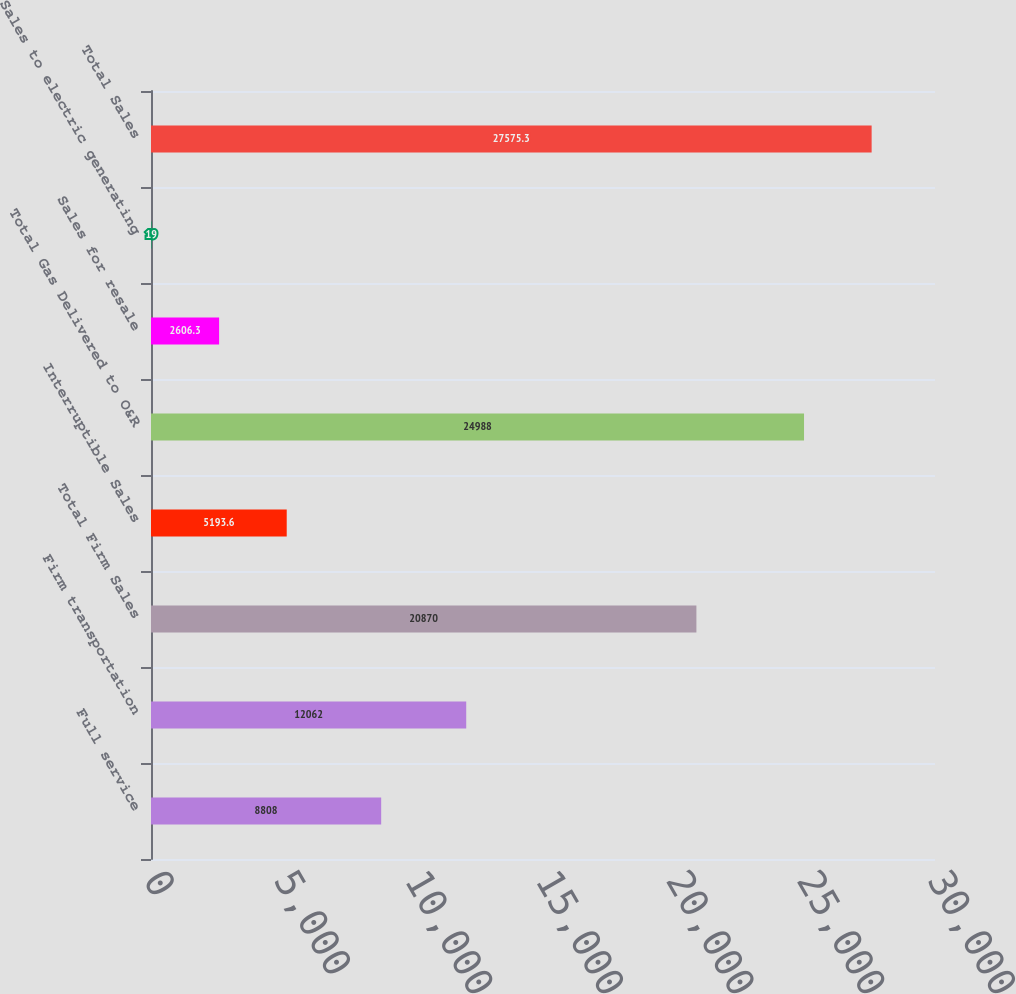<chart> <loc_0><loc_0><loc_500><loc_500><bar_chart><fcel>Full service<fcel>Firm transportation<fcel>Total Firm Sales<fcel>Interruptible Sales<fcel>Total Gas Delivered to O&R<fcel>Sales for resale<fcel>Sales to electric generating<fcel>Total Sales<nl><fcel>8808<fcel>12062<fcel>20870<fcel>5193.6<fcel>24988<fcel>2606.3<fcel>19<fcel>27575.3<nl></chart> 